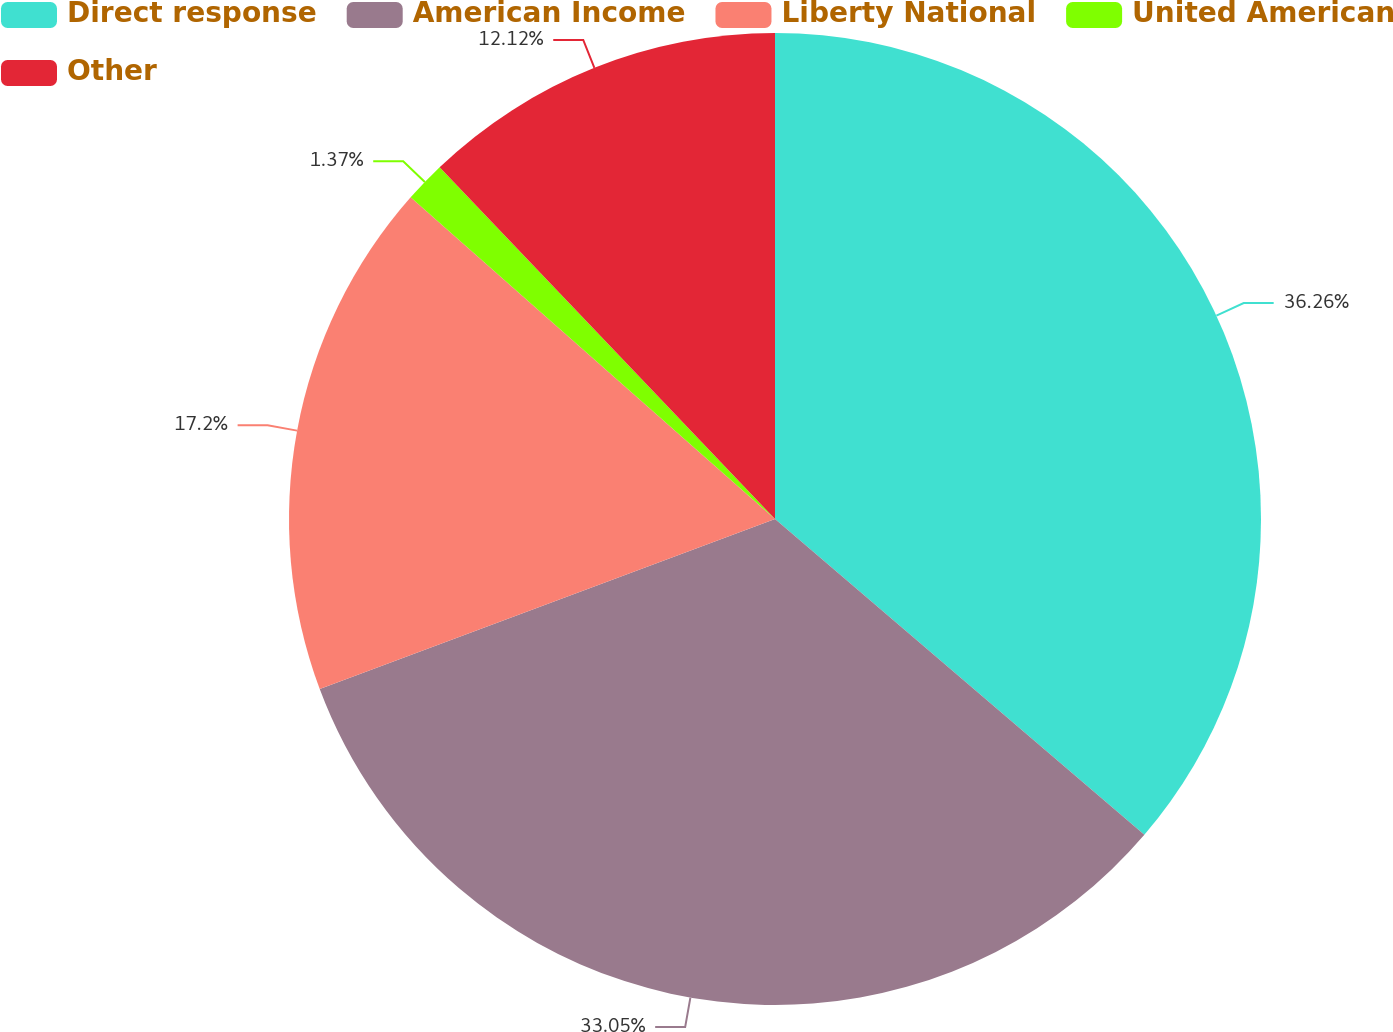Convert chart to OTSL. <chart><loc_0><loc_0><loc_500><loc_500><pie_chart><fcel>Direct response<fcel>American Income<fcel>Liberty National<fcel>United American<fcel>Other<nl><fcel>36.26%<fcel>33.05%<fcel>17.2%<fcel>1.37%<fcel>12.12%<nl></chart> 